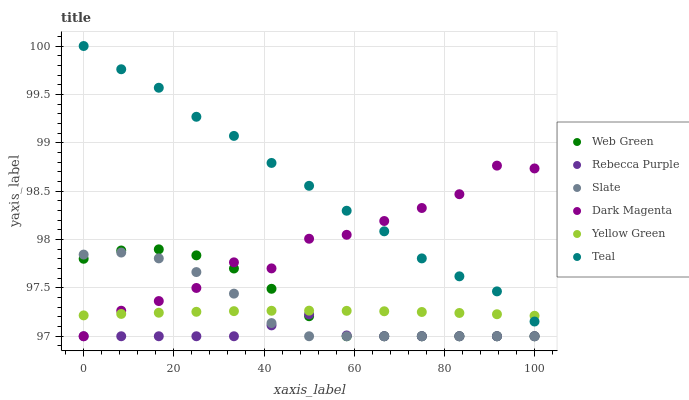Does Rebecca Purple have the minimum area under the curve?
Answer yes or no. Yes. Does Teal have the maximum area under the curve?
Answer yes or no. Yes. Does Slate have the minimum area under the curve?
Answer yes or no. No. Does Slate have the maximum area under the curve?
Answer yes or no. No. Is Yellow Green the smoothest?
Answer yes or no. Yes. Is Dark Magenta the roughest?
Answer yes or no. Yes. Is Slate the smoothest?
Answer yes or no. No. Is Slate the roughest?
Answer yes or no. No. Does Slate have the lowest value?
Answer yes or no. Yes. Does Teal have the lowest value?
Answer yes or no. No. Does Teal have the highest value?
Answer yes or no. Yes. Does Slate have the highest value?
Answer yes or no. No. Is Rebecca Purple less than Teal?
Answer yes or no. Yes. Is Teal greater than Web Green?
Answer yes or no. Yes. Does Dark Magenta intersect Slate?
Answer yes or no. Yes. Is Dark Magenta less than Slate?
Answer yes or no. No. Is Dark Magenta greater than Slate?
Answer yes or no. No. Does Rebecca Purple intersect Teal?
Answer yes or no. No. 